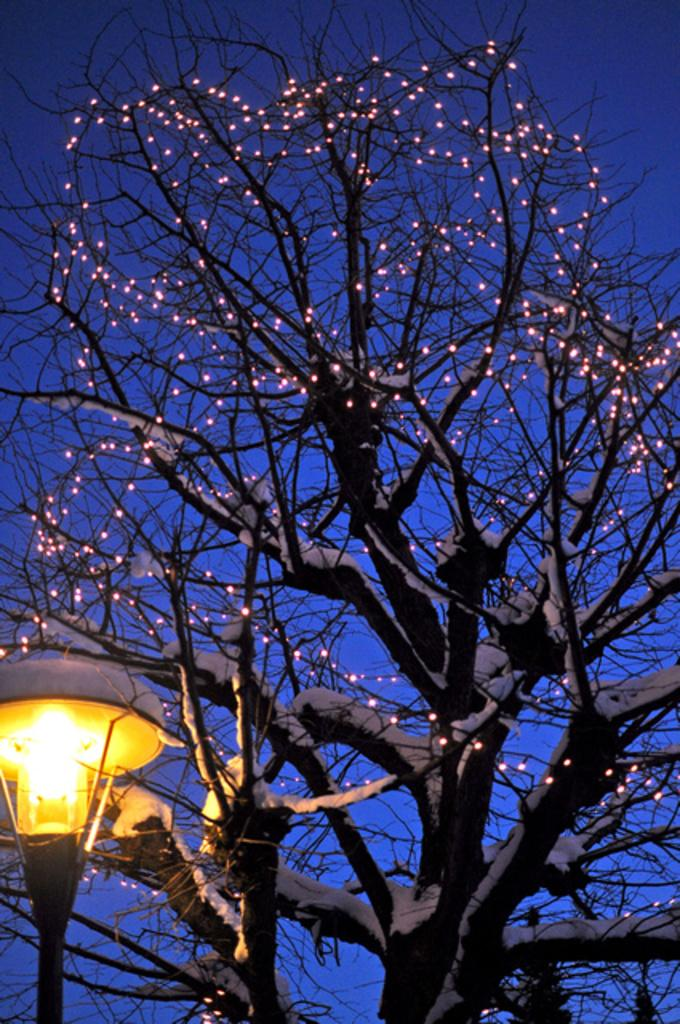What is the main object in the picture? There is a tree in the picture. What is unique about the tree in the picture? The tree has lights on it. What can be seen in the sky in the picture? The sky is visible at the top of the picture. What type of light source is present at the bottom left of the picture? There is a street light at the bottom left of the picture. Can you tell me how many basketballs are hanging from the tree in the picture? There are no basketballs present in the image; the tree has lights on it. What type of bat is sitting on the street light in the picture? There is no bat present in the picture; the image only features a tree with lights, the sky, and a street light. 